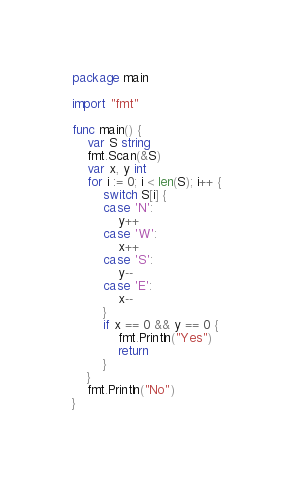Convert code to text. <code><loc_0><loc_0><loc_500><loc_500><_Go_>package main

import "fmt"

func main() {
	var S string
	fmt.Scan(&S)
	var x, y int
	for i := 0; i < len(S); i++ {
		switch S[i] {
		case 'N':
			y++
		case 'W':
			x++
		case 'S':
			y--
		case 'E':
			x--
		}
		if x == 0 && y == 0 {
			fmt.Println("Yes")
			return
		}
	}
	fmt.Println("No")
}
</code> 